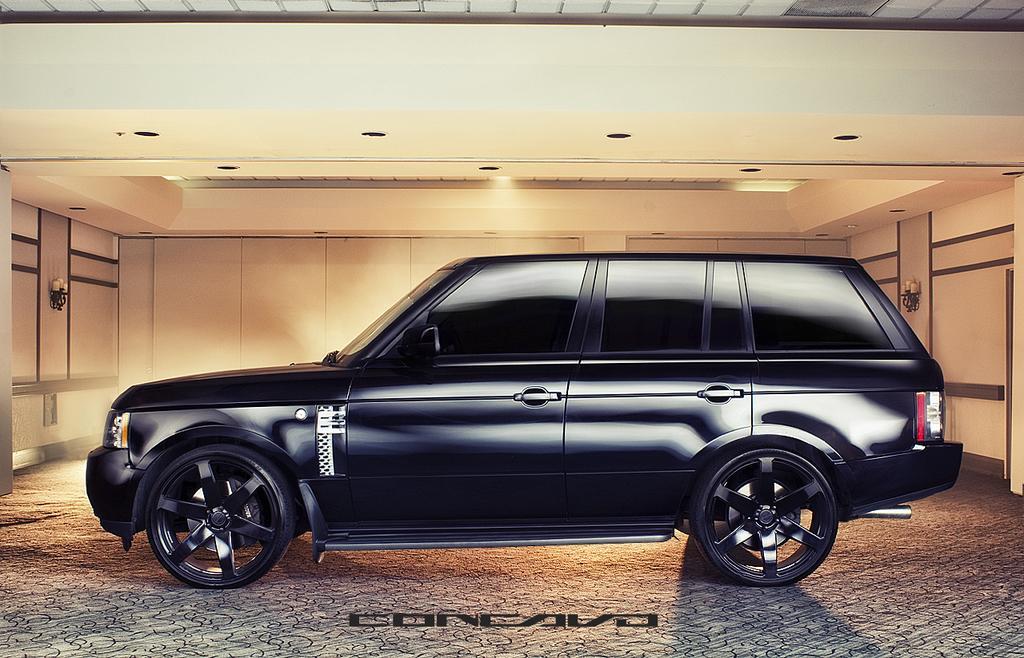In one or two sentences, can you explain what this image depicts? In this picture I can see a car in the middle, at the bottom there is the text, at the top there are ceiling lights. It is an edited image. 